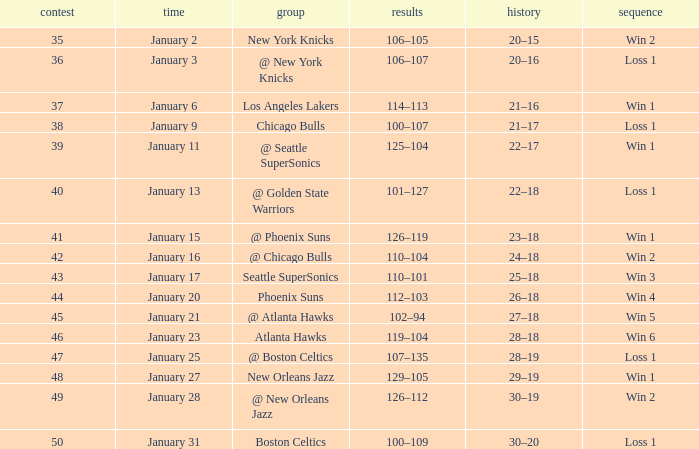What is the Team on January 20? Phoenix Suns. 